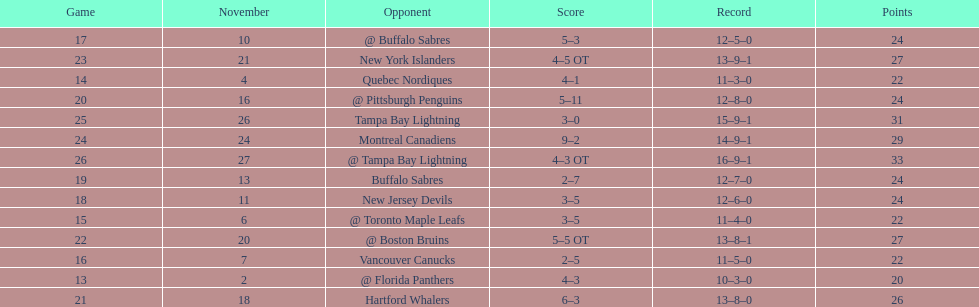What was the number of wins the philadelphia flyers had? 35. 